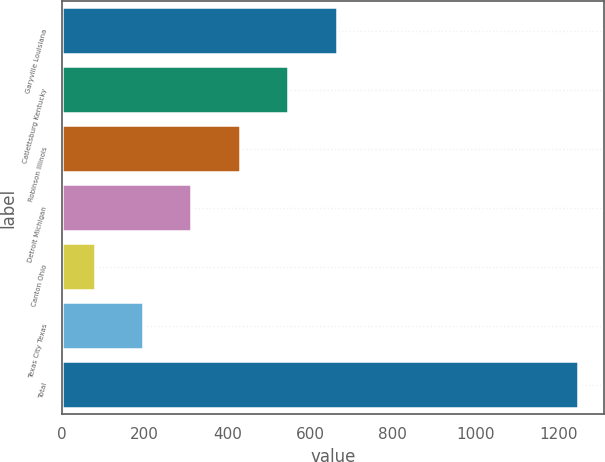Convert chart. <chart><loc_0><loc_0><loc_500><loc_500><bar_chart><fcel>Garyville Louisiana<fcel>Catlettsburg Kentucky<fcel>Robinson Illinois<fcel>Detroit Michigan<fcel>Canton Ohio<fcel>Texas City Texas<fcel>Total<nl><fcel>664<fcel>547.2<fcel>430.4<fcel>313.6<fcel>80<fcel>196.8<fcel>1248<nl></chart> 